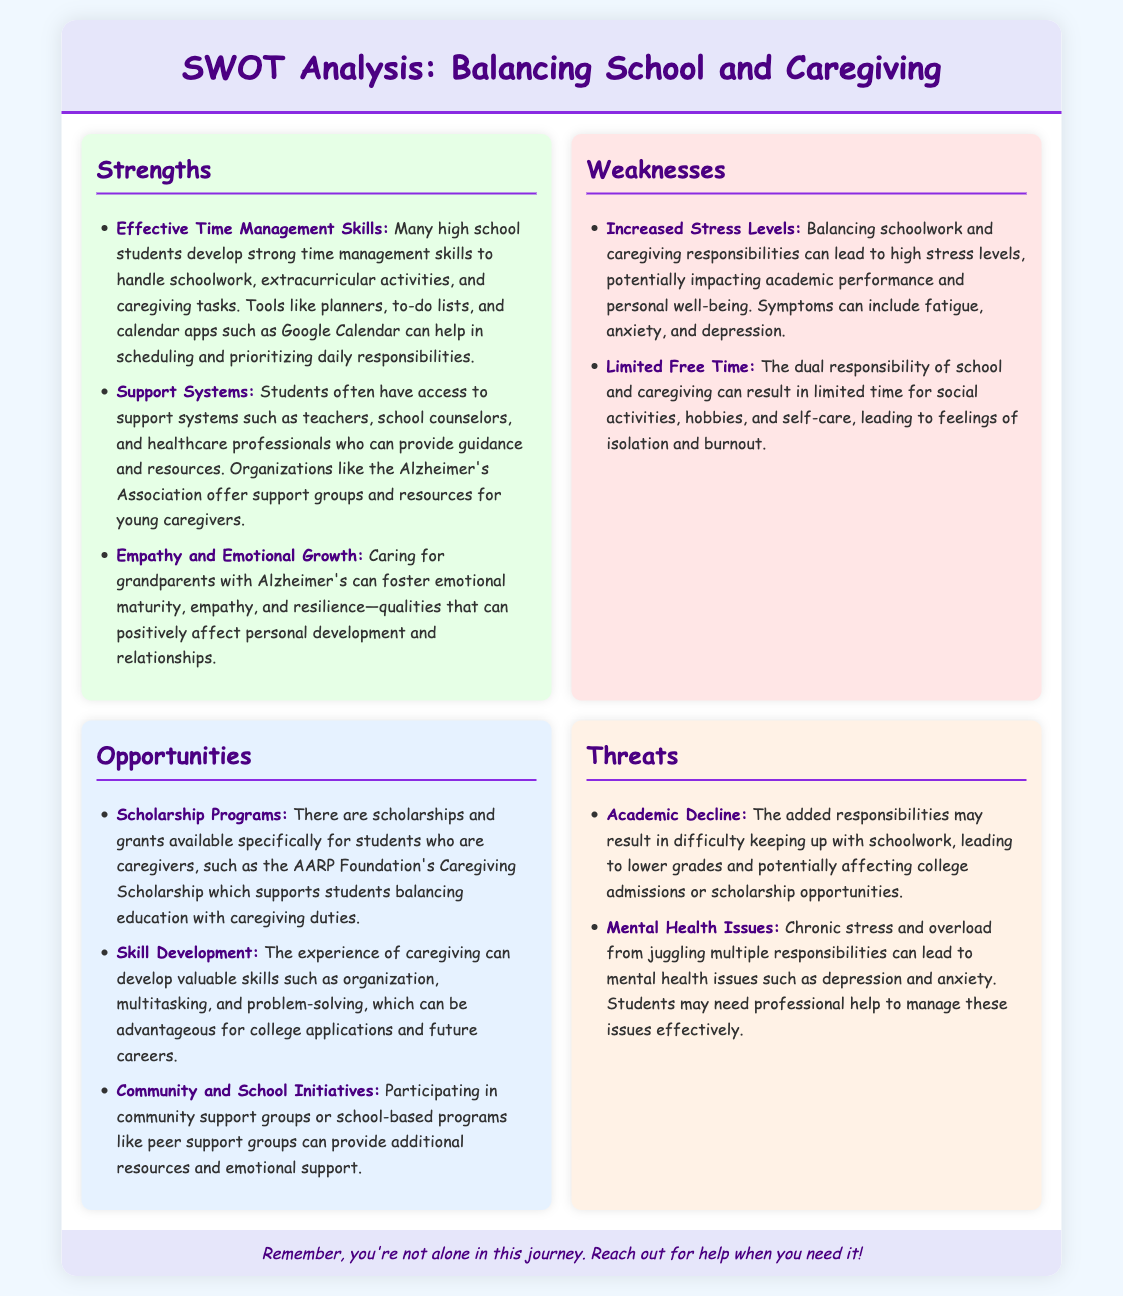What are two effective time management tools mentioned? The document lists planners and to-do lists as effective time management tools.
Answer: planners, to-do lists What organization offers support for young caregivers? The Alzheimer's Association is mentioned as a support resource for young caregivers.
Answer: Alzheimer's Association What is one major weakness listed in the document? The weakness of increased stress levels is specifically mentioned.
Answer: increased stress levels Name one opportunity available for caregiver students. The document mentions scholarships like the AARP Foundation's Caregiving Scholarship as an opportunity.
Answer: AARP Foundation's Caregiving Scholarship What can chronic stress lead to, according to the threats section? The threats section specifies that chronic stress can lead to mental health issues.
Answer: mental health issues How many strengths are specifically listed in the document? There are three strengths mentioned in the strengths section.
Answer: 3 What skill can be developed through caregiving that can help in college applications? Organization is one of the skills developed through caregiving that helps in college applications.
Answer: organization Which color represents the weaknesses section in the SWOT analysis? The weaknesses section is indicated by the color light red (or pink).
Answer: light red 